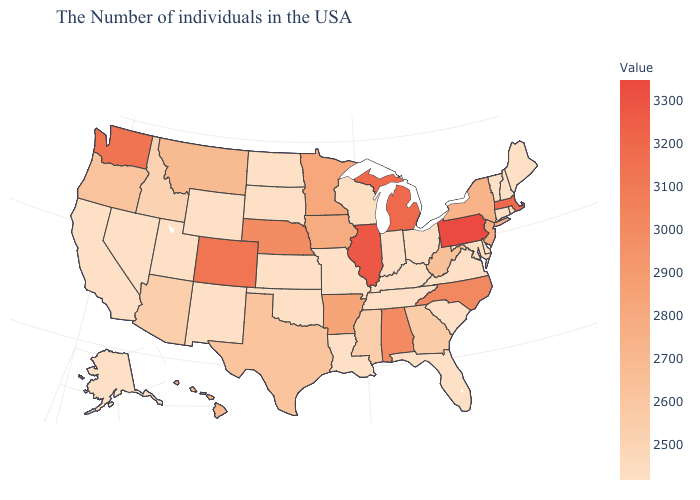Which states have the highest value in the USA?
Be succinct. Pennsylvania. Among the states that border Iowa , which have the lowest value?
Write a very short answer. Missouri, South Dakota. Among the states that border North Dakota , which have the highest value?
Concise answer only. Minnesota. Which states have the highest value in the USA?
Answer briefly. Pennsylvania. Is the legend a continuous bar?
Give a very brief answer. Yes. Is the legend a continuous bar?
Be succinct. Yes. 